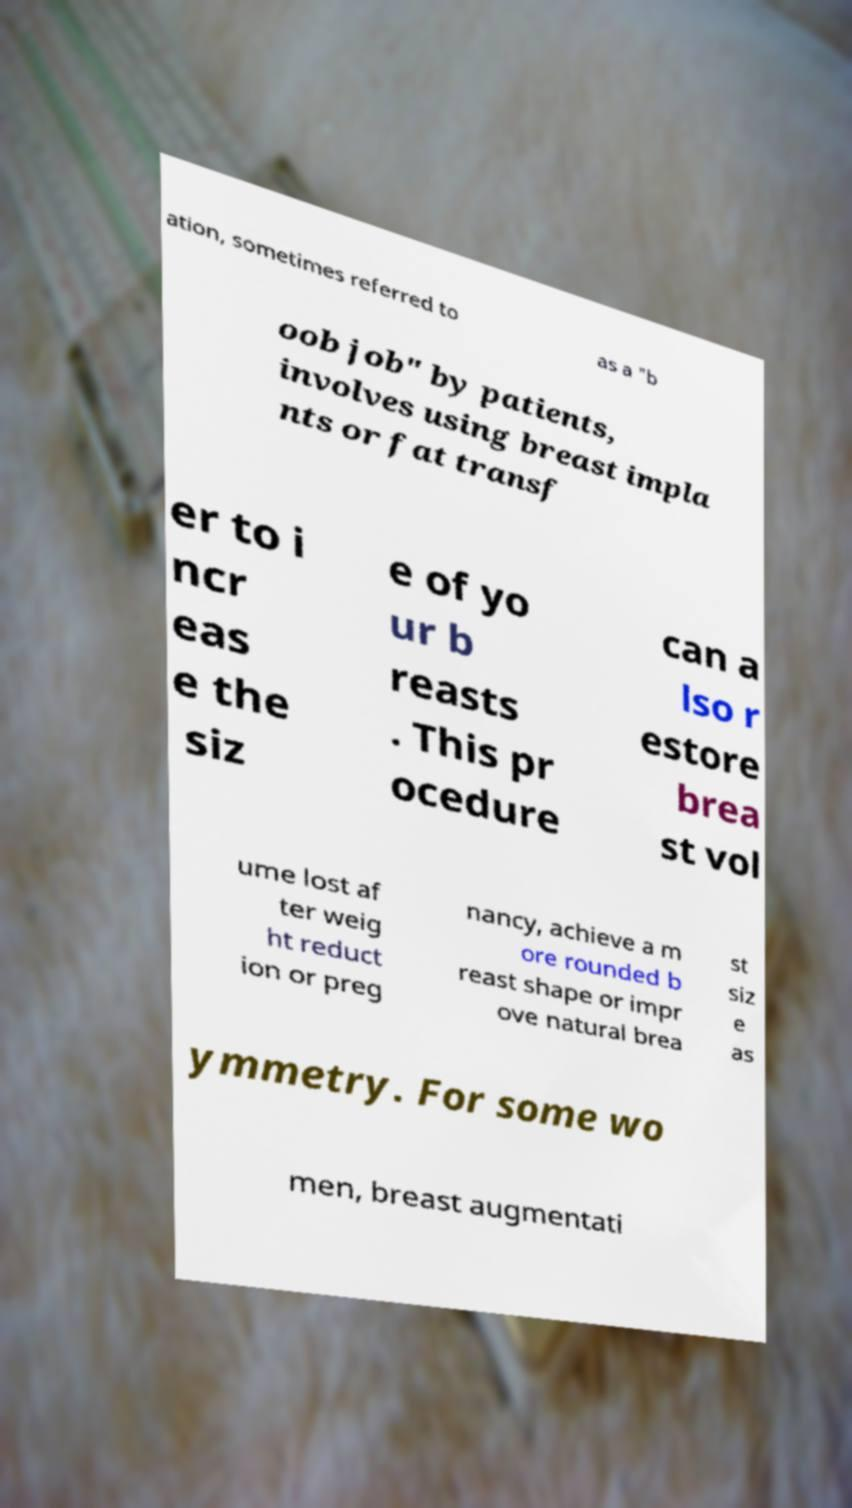I need the written content from this picture converted into text. Can you do that? ation, sometimes referred to as a "b oob job" by patients, involves using breast impla nts or fat transf er to i ncr eas e the siz e of yo ur b reasts . This pr ocedure can a lso r estore brea st vol ume lost af ter weig ht reduct ion or preg nancy, achieve a m ore rounded b reast shape or impr ove natural brea st siz e as ymmetry. For some wo men, breast augmentati 